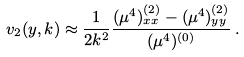Convert formula to latex. <formula><loc_0><loc_0><loc_500><loc_500>v _ { 2 } ( y , k ) \approx \frac { 1 } { 2 k ^ { 2 } } \frac { ( \mu ^ { 4 } ) _ { x x } ^ { ( 2 ) } - ( \mu ^ { 4 } ) _ { y y } ^ { ( 2 ) } } { ( \mu ^ { 4 } ) ^ { ( 0 ) } } \, .</formula> 